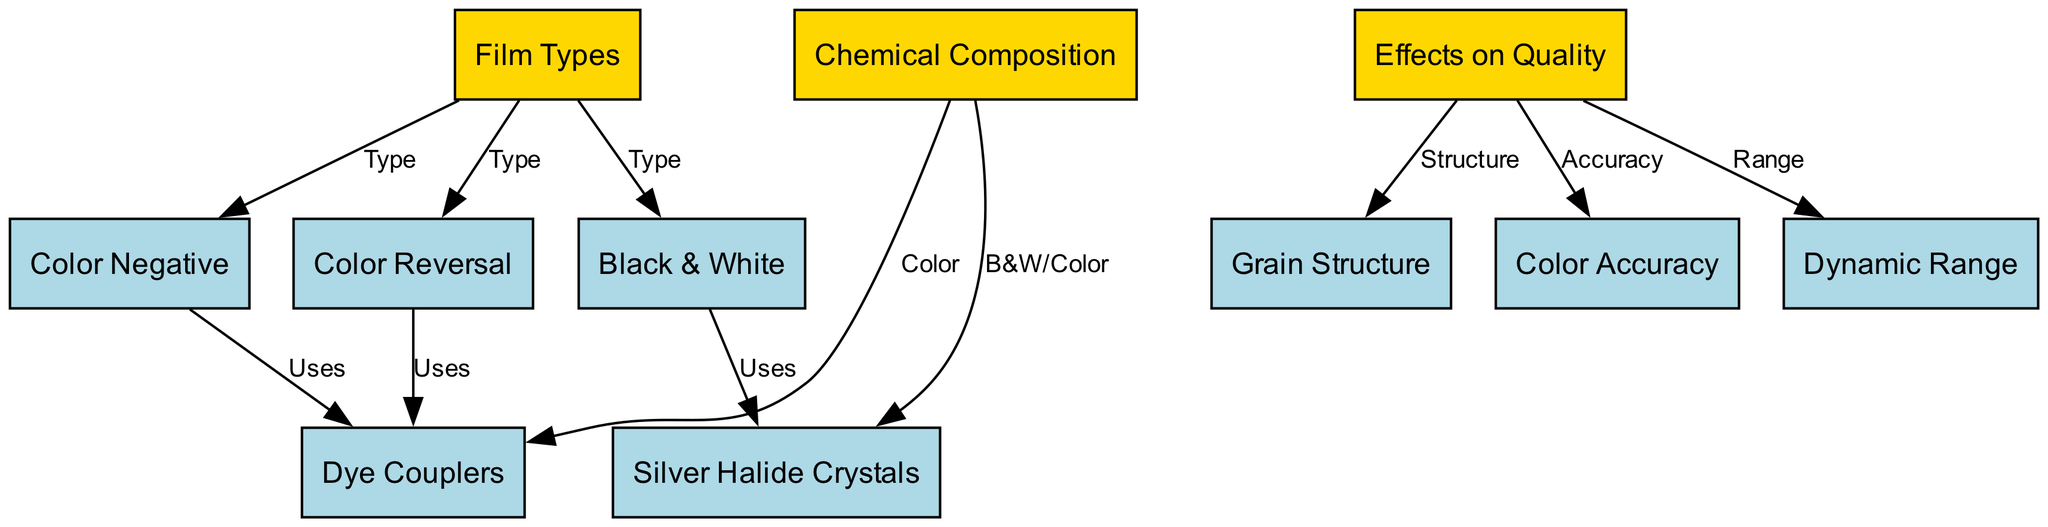What are the three types of film mentioned? The diagram lists three types of film: Black & White, Color Negative, and Color Reversal. These are clearly outlined as sub-nodes under the main node 'Film Types'.
Answer: Black & White, Color Negative, Color Reversal Which film type uses silver halide crystals? Silver halide crystals are connected directly to the Black & White film type, indicating its use. The diagram clearly shows that Black & White films involve silver halide crystals in their chemical composition.
Answer: Black & White What are the three components of chemical composition in color films? In the diagram, Dye Couplers are linked to both Color Negative and Color Reversal film types, indicating that these films use dye couplers in their chemical composition. Since both types fall under 'Color', we conclude there are two main components: silver halide crystals for B&W and dye couplers for color types.
Answer: Dye Couplers How many effects on quality are listed in the diagram? The diagram outlines three effects on quality: Grain Structure, Color Accuracy, and Dynamic Range. All of these are sub-nodes under the main node 'Effects on Quality', indicating a straightforward list of three.
Answer: Three What film type is associated with dye couplers? The diagram indicates that both Color Negative and Color Reversal film types use dye couplers in their chemical composition. The connections from these sub-nodes show that dye couplers are specifically associated with these two film types.
Answer: Color Negative and Color Reversal Which effect on quality is directly related to structure? The diagram shows a direct link from the 'Effects on Quality' node to 'Grain Structure'. This connection demonstrates that grain structure is identified as a factor affecting quality in the visual information presented.
Answer: Grain Structure Which color film type is associated with the greatest dynamic range? While the diagram outlines the different effects, it does not specify which film type possesses the greatest dynamic range. Thus, no explicit answer can be derived solely from the diagram without additional context.
Answer: Not specified How many sub-nodes are under 'Film Types'? The 'Film Types' node directly connects to three sub-nodes: Black & White, Color Negative, and Color Reversal. By counting these connections, we confirm the number of sub-nodes associated with 'Film Types'.
Answer: Three What is the relationship between chemical composition and effects on quality? The diagram shows two main aspects: Chemical Composition leads to distinct film types (either using silver halide or dye couplers), while the Effects on Quality are different factors like grain structure, color accuracy, and dynamic range. Thus, these two main nodes are interconnected through their respective sub-elements, influencing each other in terms of film quality outputs.
Answer: Interconnected 